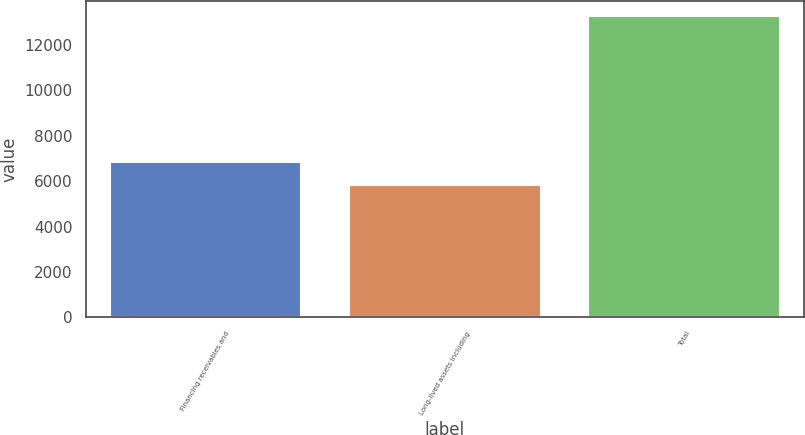<chart> <loc_0><loc_0><loc_500><loc_500><bar_chart><fcel>Financing receivables and<fcel>Long-lived assets including<fcel>Total<nl><fcel>6833<fcel>5811<fcel>13267<nl></chart> 